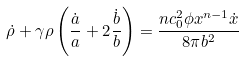<formula> <loc_0><loc_0><loc_500><loc_500>\dot { \rho } + \gamma \rho \left ( \frac { \dot { a } } { a } + 2 \frac { \dot { b } } { b } \right ) = \frac { n c _ { 0 } ^ { 2 } \phi x ^ { n - 1 } \dot { x } } { 8 \pi b ^ { 2 } }</formula> 